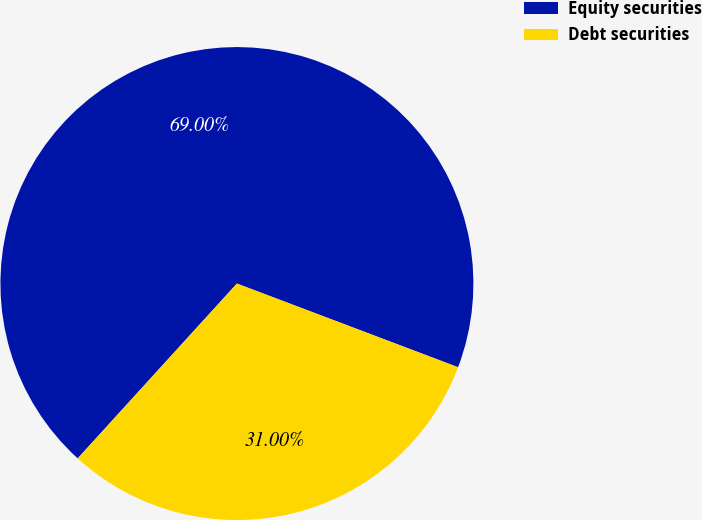<chart> <loc_0><loc_0><loc_500><loc_500><pie_chart><fcel>Equity securities<fcel>Debt securities<nl><fcel>69.0%<fcel>31.0%<nl></chart> 